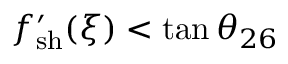<formula> <loc_0><loc_0><loc_500><loc_500>f _ { s h } ^ { \prime } ( \xi ) < \tan \theta _ { 2 6 }</formula> 